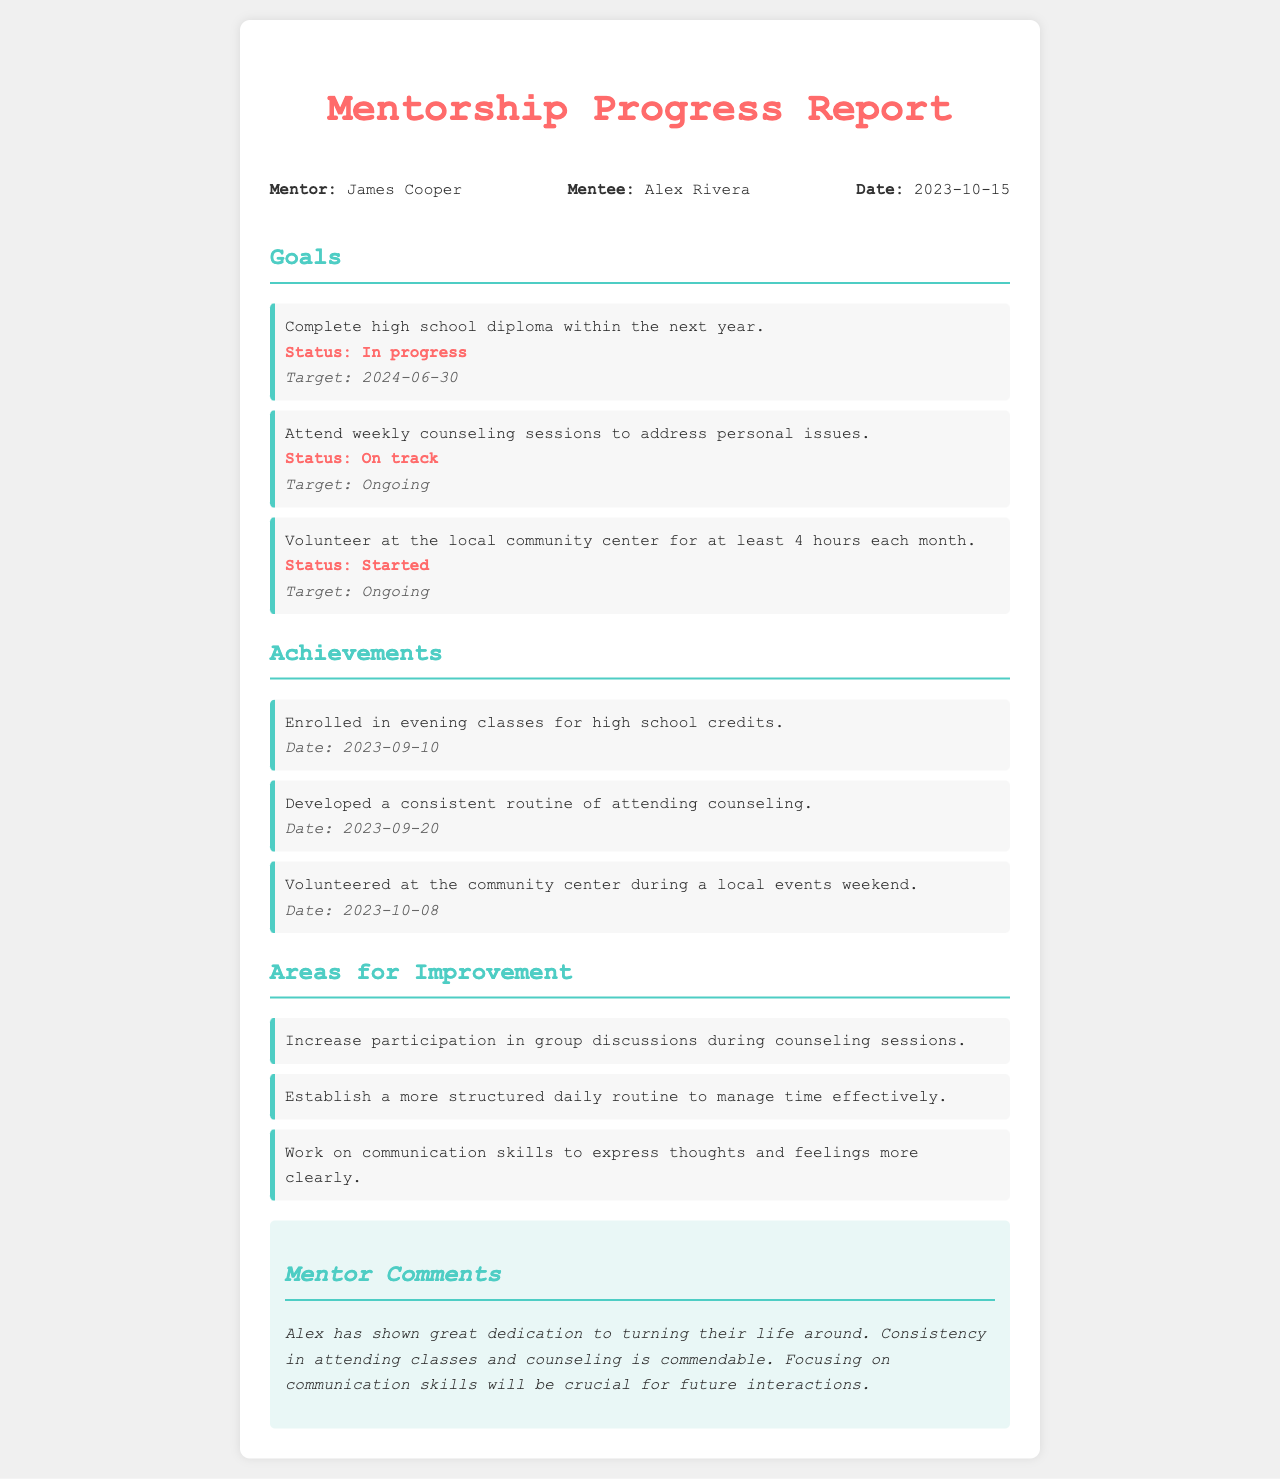What is the mentor's name? The mentor's name is mentioned in the document as "James Cooper."
Answer: James Cooper What is the mentee's name? The mentee's name is listed as "Alex Rivera."
Answer: Alex Rivera What is the target date for completing the high school diploma? The document specifies that the target date for completing the high school diploma is "2024-06-30."
Answer: 2024-06-30 How many hours of volunteering are required each month? The document states that the mentee is expected to volunteer for "at least 4 hours" each month.
Answer: at least 4 hours What achievement was noted on 2023-10-08? The document records the achievement of volunteering at the community center during a local events weekend on this date.
Answer: Volunteered at the community center during local events weekend Which area for improvement involves communication? The document mentions that the mentee needs to work on "communication skills to express thoughts and feelings more clearly."
Answer: communication skills What is the status of attending weekly counseling sessions? The status indicated in the document is "On track" for attending weekly counseling sessions.
Answer: On track What is the mentor's comment regarding Alex's consistency? The mentor notes that "Consistency in attending classes and counseling is commendable."
Answer: Consistency in attending classes and counseling is commendable What is one goal listed that is "In progress"? The goal of completing the high school diploma is marked as "In progress."
Answer: Complete high school diploma 